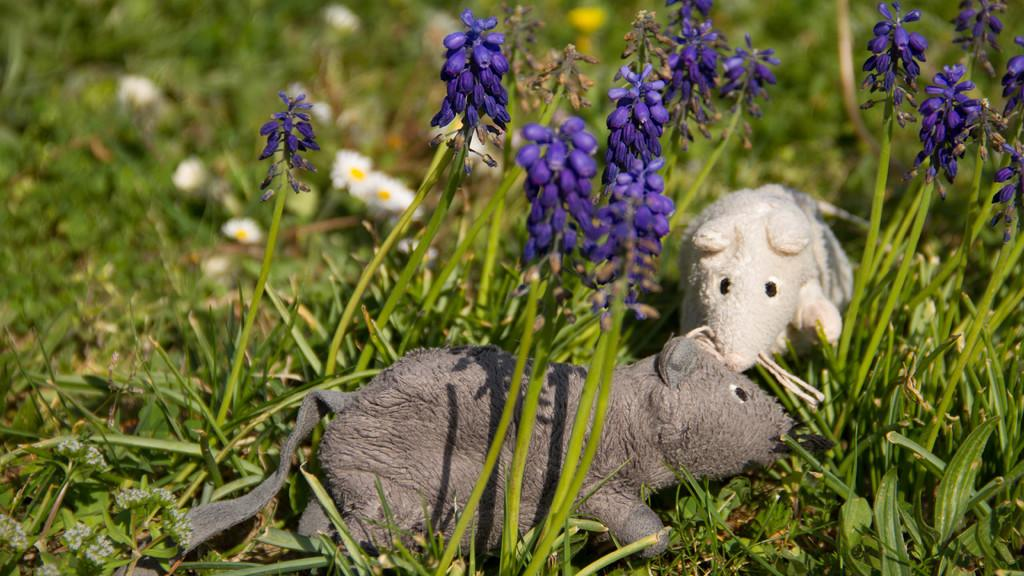What is the main subject of the image? There are depictions of rats in the center of the image. What type of plants can be seen in the image? There are flower plants in the image. What type of vegetation is present in the image? There is grass in the image. What type of market can be seen in the image? There is no market present in the image; it features depictions of rats, flower plants, and grass. Can you hear any crying in the image? The image is silent, and there is no indication of any crying or sound. 